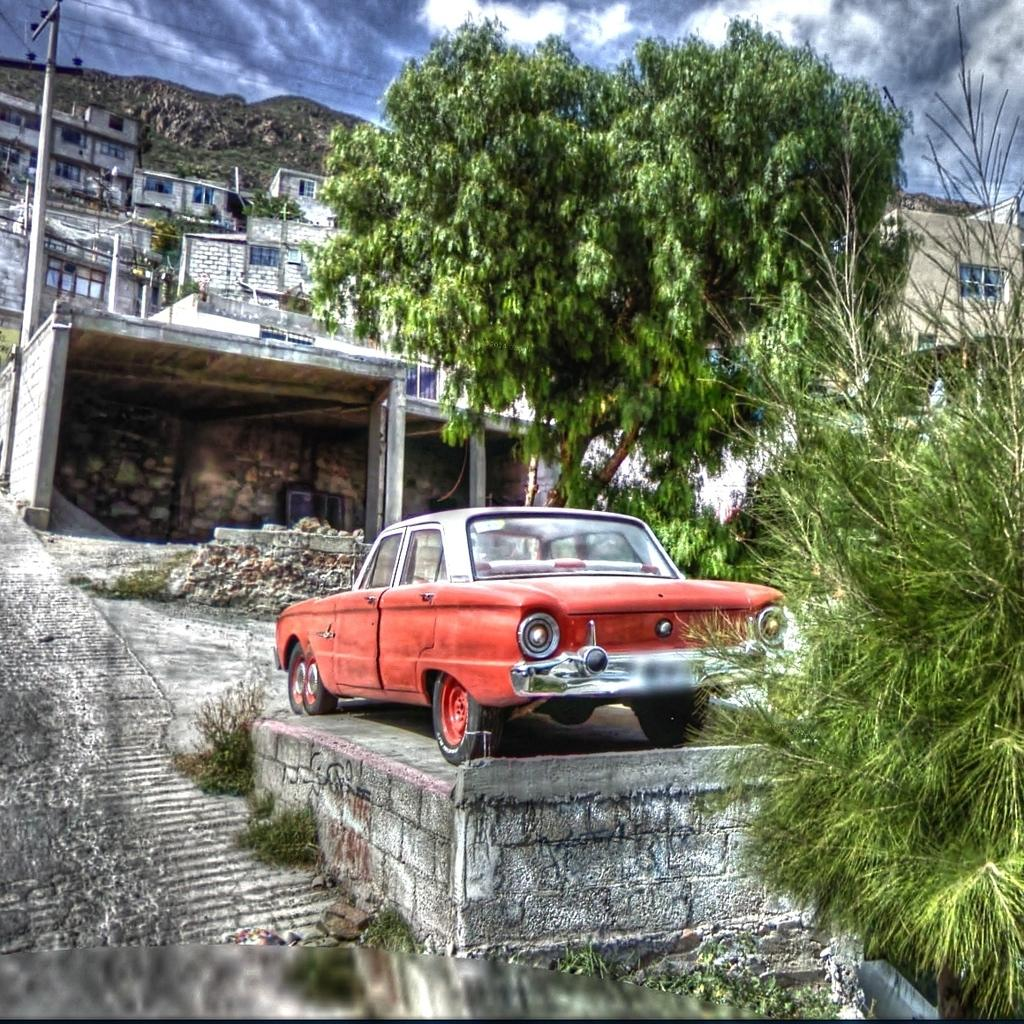What type of structures can be seen in the image? There are many houses and a building in the image. What mode of transportation is visible in the image? There is a car in the image. What is the weather like in the image? The sky is cloudy in the image. What type of vegetation is present in the image? There is a tree in the image. Where is the father standing in the image? There is no father present in the image. Is there a hose connected to the car in the image? There is no hose visible in the image. 